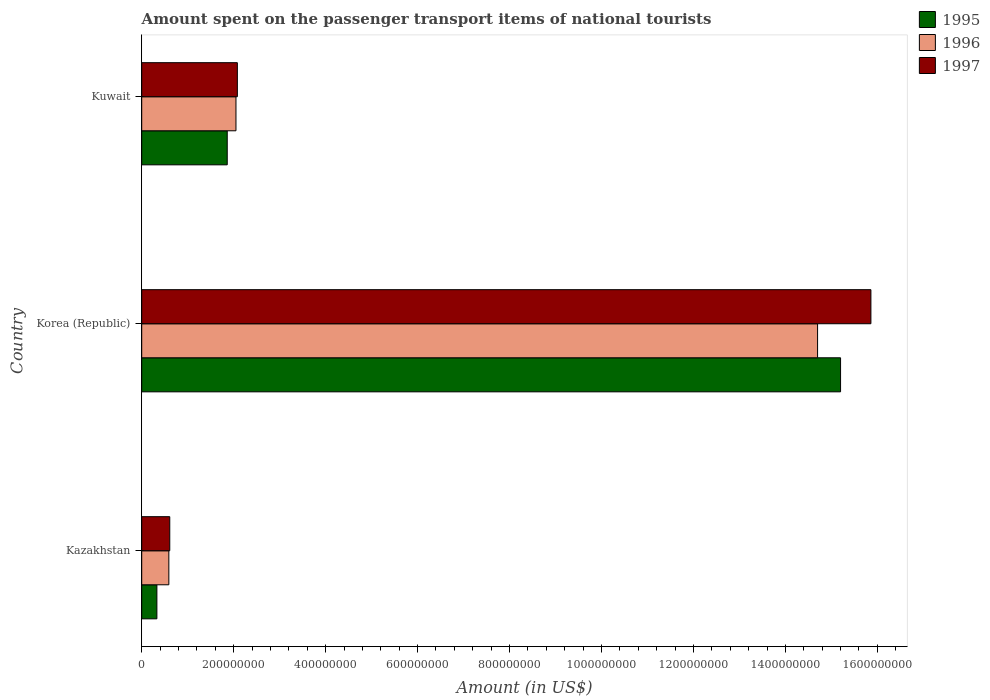How many groups of bars are there?
Your answer should be compact. 3. What is the label of the 2nd group of bars from the top?
Provide a succinct answer. Korea (Republic). What is the amount spent on the passenger transport items of national tourists in 1997 in Kazakhstan?
Your response must be concise. 6.10e+07. Across all countries, what is the maximum amount spent on the passenger transport items of national tourists in 1997?
Provide a succinct answer. 1.59e+09. Across all countries, what is the minimum amount spent on the passenger transport items of national tourists in 1995?
Your answer should be very brief. 3.30e+07. In which country was the amount spent on the passenger transport items of national tourists in 1997 maximum?
Your answer should be very brief. Korea (Republic). In which country was the amount spent on the passenger transport items of national tourists in 1995 minimum?
Keep it short and to the point. Kazakhstan. What is the total amount spent on the passenger transport items of national tourists in 1996 in the graph?
Provide a short and direct response. 1.73e+09. What is the difference between the amount spent on the passenger transport items of national tourists in 1996 in Korea (Republic) and that in Kuwait?
Your answer should be very brief. 1.26e+09. What is the difference between the amount spent on the passenger transport items of national tourists in 1997 in Kazakhstan and the amount spent on the passenger transport items of national tourists in 1996 in Kuwait?
Your answer should be compact. -1.44e+08. What is the average amount spent on the passenger transport items of national tourists in 1997 per country?
Your answer should be compact. 6.18e+08. What is the difference between the amount spent on the passenger transport items of national tourists in 1996 and amount spent on the passenger transport items of national tourists in 1997 in Korea (Republic)?
Provide a succinct answer. -1.16e+08. What is the ratio of the amount spent on the passenger transport items of national tourists in 1996 in Kazakhstan to that in Kuwait?
Provide a short and direct response. 0.29. Is the amount spent on the passenger transport items of national tourists in 1996 in Kazakhstan less than that in Kuwait?
Offer a terse response. Yes. Is the difference between the amount spent on the passenger transport items of national tourists in 1996 in Korea (Republic) and Kuwait greater than the difference between the amount spent on the passenger transport items of national tourists in 1997 in Korea (Republic) and Kuwait?
Your answer should be very brief. No. What is the difference between the highest and the second highest amount spent on the passenger transport items of national tourists in 1997?
Offer a terse response. 1.38e+09. What is the difference between the highest and the lowest amount spent on the passenger transport items of national tourists in 1995?
Offer a very short reply. 1.49e+09. What does the 3rd bar from the bottom in Korea (Republic) represents?
Offer a very short reply. 1997. Is it the case that in every country, the sum of the amount spent on the passenger transport items of national tourists in 1995 and amount spent on the passenger transport items of national tourists in 1996 is greater than the amount spent on the passenger transport items of national tourists in 1997?
Provide a succinct answer. Yes. How many bars are there?
Your answer should be compact. 9. Are all the bars in the graph horizontal?
Ensure brevity in your answer.  Yes. Does the graph contain any zero values?
Provide a short and direct response. No. How many legend labels are there?
Provide a short and direct response. 3. How are the legend labels stacked?
Make the answer very short. Vertical. What is the title of the graph?
Offer a very short reply. Amount spent on the passenger transport items of national tourists. What is the label or title of the X-axis?
Your answer should be compact. Amount (in US$). What is the Amount (in US$) in 1995 in Kazakhstan?
Make the answer very short. 3.30e+07. What is the Amount (in US$) of 1996 in Kazakhstan?
Offer a terse response. 5.90e+07. What is the Amount (in US$) in 1997 in Kazakhstan?
Your answer should be very brief. 6.10e+07. What is the Amount (in US$) of 1995 in Korea (Republic)?
Keep it short and to the point. 1.52e+09. What is the Amount (in US$) of 1996 in Korea (Republic)?
Ensure brevity in your answer.  1.47e+09. What is the Amount (in US$) of 1997 in Korea (Republic)?
Your answer should be very brief. 1.59e+09. What is the Amount (in US$) in 1995 in Kuwait?
Offer a terse response. 1.86e+08. What is the Amount (in US$) in 1996 in Kuwait?
Your answer should be compact. 2.05e+08. What is the Amount (in US$) in 1997 in Kuwait?
Keep it short and to the point. 2.08e+08. Across all countries, what is the maximum Amount (in US$) of 1995?
Make the answer very short. 1.52e+09. Across all countries, what is the maximum Amount (in US$) of 1996?
Offer a very short reply. 1.47e+09. Across all countries, what is the maximum Amount (in US$) in 1997?
Provide a short and direct response. 1.59e+09. Across all countries, what is the minimum Amount (in US$) in 1995?
Keep it short and to the point. 3.30e+07. Across all countries, what is the minimum Amount (in US$) of 1996?
Keep it short and to the point. 5.90e+07. Across all countries, what is the minimum Amount (in US$) in 1997?
Ensure brevity in your answer.  6.10e+07. What is the total Amount (in US$) of 1995 in the graph?
Your response must be concise. 1.74e+09. What is the total Amount (in US$) in 1996 in the graph?
Give a very brief answer. 1.73e+09. What is the total Amount (in US$) in 1997 in the graph?
Ensure brevity in your answer.  1.86e+09. What is the difference between the Amount (in US$) of 1995 in Kazakhstan and that in Korea (Republic)?
Offer a terse response. -1.49e+09. What is the difference between the Amount (in US$) in 1996 in Kazakhstan and that in Korea (Republic)?
Your answer should be very brief. -1.41e+09. What is the difference between the Amount (in US$) of 1997 in Kazakhstan and that in Korea (Republic)?
Provide a succinct answer. -1.52e+09. What is the difference between the Amount (in US$) in 1995 in Kazakhstan and that in Kuwait?
Make the answer very short. -1.53e+08. What is the difference between the Amount (in US$) of 1996 in Kazakhstan and that in Kuwait?
Keep it short and to the point. -1.46e+08. What is the difference between the Amount (in US$) in 1997 in Kazakhstan and that in Kuwait?
Make the answer very short. -1.47e+08. What is the difference between the Amount (in US$) of 1995 in Korea (Republic) and that in Kuwait?
Ensure brevity in your answer.  1.33e+09. What is the difference between the Amount (in US$) of 1996 in Korea (Republic) and that in Kuwait?
Your answer should be very brief. 1.26e+09. What is the difference between the Amount (in US$) in 1997 in Korea (Republic) and that in Kuwait?
Your response must be concise. 1.38e+09. What is the difference between the Amount (in US$) of 1995 in Kazakhstan and the Amount (in US$) of 1996 in Korea (Republic)?
Your response must be concise. -1.44e+09. What is the difference between the Amount (in US$) in 1995 in Kazakhstan and the Amount (in US$) in 1997 in Korea (Republic)?
Provide a short and direct response. -1.55e+09. What is the difference between the Amount (in US$) of 1996 in Kazakhstan and the Amount (in US$) of 1997 in Korea (Republic)?
Your response must be concise. -1.53e+09. What is the difference between the Amount (in US$) in 1995 in Kazakhstan and the Amount (in US$) in 1996 in Kuwait?
Provide a succinct answer. -1.72e+08. What is the difference between the Amount (in US$) of 1995 in Kazakhstan and the Amount (in US$) of 1997 in Kuwait?
Give a very brief answer. -1.75e+08. What is the difference between the Amount (in US$) in 1996 in Kazakhstan and the Amount (in US$) in 1997 in Kuwait?
Ensure brevity in your answer.  -1.49e+08. What is the difference between the Amount (in US$) in 1995 in Korea (Republic) and the Amount (in US$) in 1996 in Kuwait?
Your response must be concise. 1.32e+09. What is the difference between the Amount (in US$) in 1995 in Korea (Republic) and the Amount (in US$) in 1997 in Kuwait?
Your answer should be very brief. 1.31e+09. What is the difference between the Amount (in US$) of 1996 in Korea (Republic) and the Amount (in US$) of 1997 in Kuwait?
Make the answer very short. 1.26e+09. What is the average Amount (in US$) in 1995 per country?
Ensure brevity in your answer.  5.80e+08. What is the average Amount (in US$) of 1996 per country?
Make the answer very short. 5.78e+08. What is the average Amount (in US$) of 1997 per country?
Provide a short and direct response. 6.18e+08. What is the difference between the Amount (in US$) of 1995 and Amount (in US$) of 1996 in Kazakhstan?
Provide a succinct answer. -2.60e+07. What is the difference between the Amount (in US$) in 1995 and Amount (in US$) in 1997 in Kazakhstan?
Offer a very short reply. -2.80e+07. What is the difference between the Amount (in US$) of 1995 and Amount (in US$) of 1997 in Korea (Republic)?
Your response must be concise. -6.60e+07. What is the difference between the Amount (in US$) of 1996 and Amount (in US$) of 1997 in Korea (Republic)?
Your answer should be compact. -1.16e+08. What is the difference between the Amount (in US$) of 1995 and Amount (in US$) of 1996 in Kuwait?
Offer a very short reply. -1.90e+07. What is the difference between the Amount (in US$) in 1995 and Amount (in US$) in 1997 in Kuwait?
Ensure brevity in your answer.  -2.20e+07. What is the ratio of the Amount (in US$) of 1995 in Kazakhstan to that in Korea (Republic)?
Keep it short and to the point. 0.02. What is the ratio of the Amount (in US$) in 1996 in Kazakhstan to that in Korea (Republic)?
Provide a short and direct response. 0.04. What is the ratio of the Amount (in US$) of 1997 in Kazakhstan to that in Korea (Republic)?
Ensure brevity in your answer.  0.04. What is the ratio of the Amount (in US$) of 1995 in Kazakhstan to that in Kuwait?
Provide a short and direct response. 0.18. What is the ratio of the Amount (in US$) of 1996 in Kazakhstan to that in Kuwait?
Offer a very short reply. 0.29. What is the ratio of the Amount (in US$) in 1997 in Kazakhstan to that in Kuwait?
Provide a succinct answer. 0.29. What is the ratio of the Amount (in US$) in 1995 in Korea (Republic) to that in Kuwait?
Give a very brief answer. 8.17. What is the ratio of the Amount (in US$) in 1996 in Korea (Republic) to that in Kuwait?
Offer a very short reply. 7.17. What is the ratio of the Amount (in US$) of 1997 in Korea (Republic) to that in Kuwait?
Keep it short and to the point. 7.62. What is the difference between the highest and the second highest Amount (in US$) in 1995?
Ensure brevity in your answer.  1.33e+09. What is the difference between the highest and the second highest Amount (in US$) of 1996?
Your answer should be very brief. 1.26e+09. What is the difference between the highest and the second highest Amount (in US$) in 1997?
Provide a short and direct response. 1.38e+09. What is the difference between the highest and the lowest Amount (in US$) of 1995?
Provide a succinct answer. 1.49e+09. What is the difference between the highest and the lowest Amount (in US$) of 1996?
Ensure brevity in your answer.  1.41e+09. What is the difference between the highest and the lowest Amount (in US$) in 1997?
Give a very brief answer. 1.52e+09. 